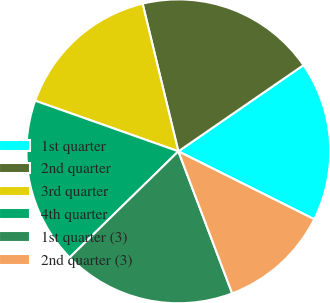Convert chart to OTSL. <chart><loc_0><loc_0><loc_500><loc_500><pie_chart><fcel>1st quarter<fcel>2nd quarter<fcel>3rd quarter<fcel>4th quarter<fcel>1st quarter (3)<fcel>2nd quarter (3)<nl><fcel>16.98%<fcel>19.18%<fcel>15.81%<fcel>17.72%<fcel>18.45%<fcel>11.86%<nl></chart> 